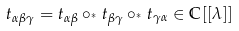<formula> <loc_0><loc_0><loc_500><loc_500>t _ { \alpha \beta \gamma } = t _ { \alpha \beta } \circ _ { ^ { * } } t _ { \beta \gamma } \circ _ { ^ { * } } t _ { \gamma \alpha } \in \mathbb { C } [ [ \lambda ] ]</formula> 